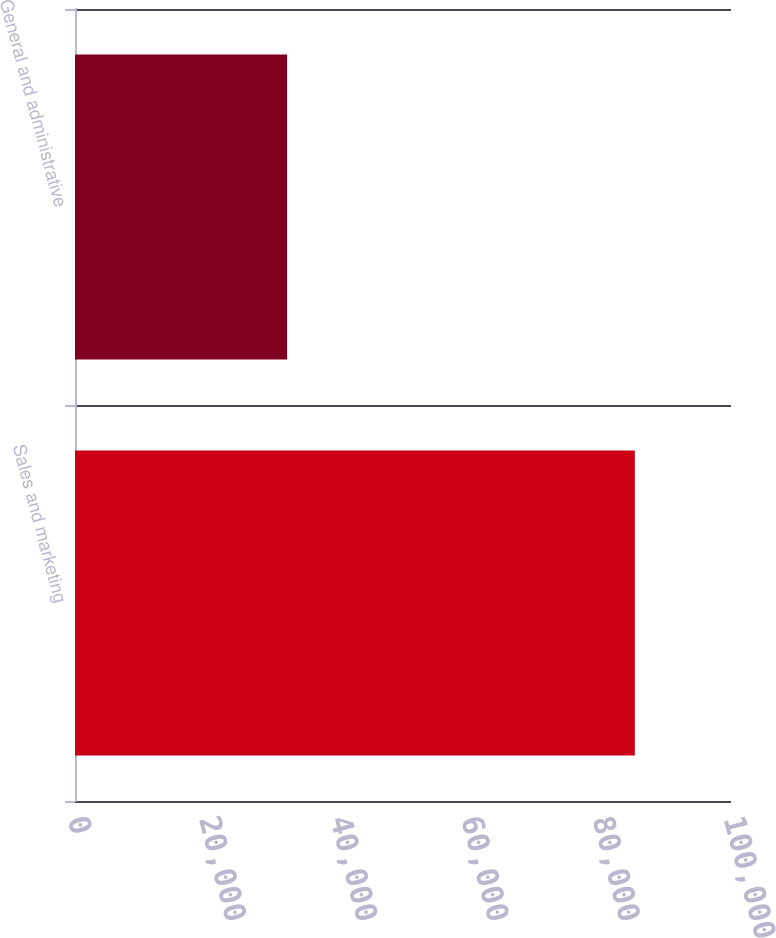Convert chart to OTSL. <chart><loc_0><loc_0><loc_500><loc_500><bar_chart><fcel>Sales and marketing<fcel>General and administrative<nl><fcel>85338<fcel>32331<nl></chart> 